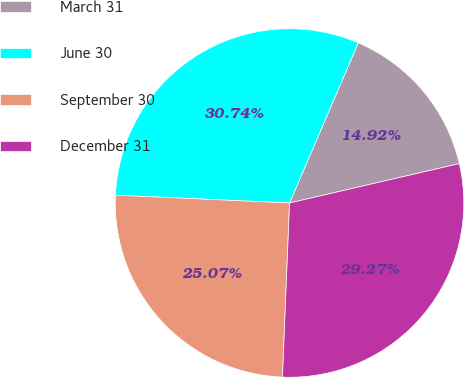Convert chart to OTSL. <chart><loc_0><loc_0><loc_500><loc_500><pie_chart><fcel>March 31<fcel>June 30<fcel>September 30<fcel>December 31<nl><fcel>14.92%<fcel>30.74%<fcel>25.07%<fcel>29.27%<nl></chart> 